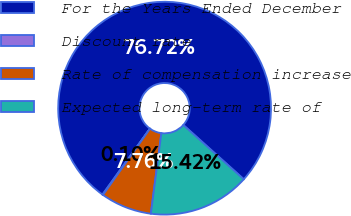Convert chart. <chart><loc_0><loc_0><loc_500><loc_500><pie_chart><fcel>For the Years Ended December<fcel>Discount rate<fcel>Rate of compensation increase<fcel>Expected long-term rate of<nl><fcel>76.72%<fcel>0.1%<fcel>7.76%<fcel>15.42%<nl></chart> 